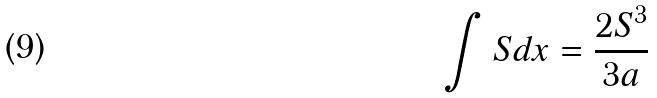<formula> <loc_0><loc_0><loc_500><loc_500>\int S d x = \frac { 2 S ^ { 3 } } { 3 a }</formula> 